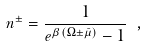<formula> <loc_0><loc_0><loc_500><loc_500>n ^ { \pm } = \frac { 1 } { e ^ { \beta ( \Omega \pm \bar { \mu } ) } - 1 } \ ,</formula> 